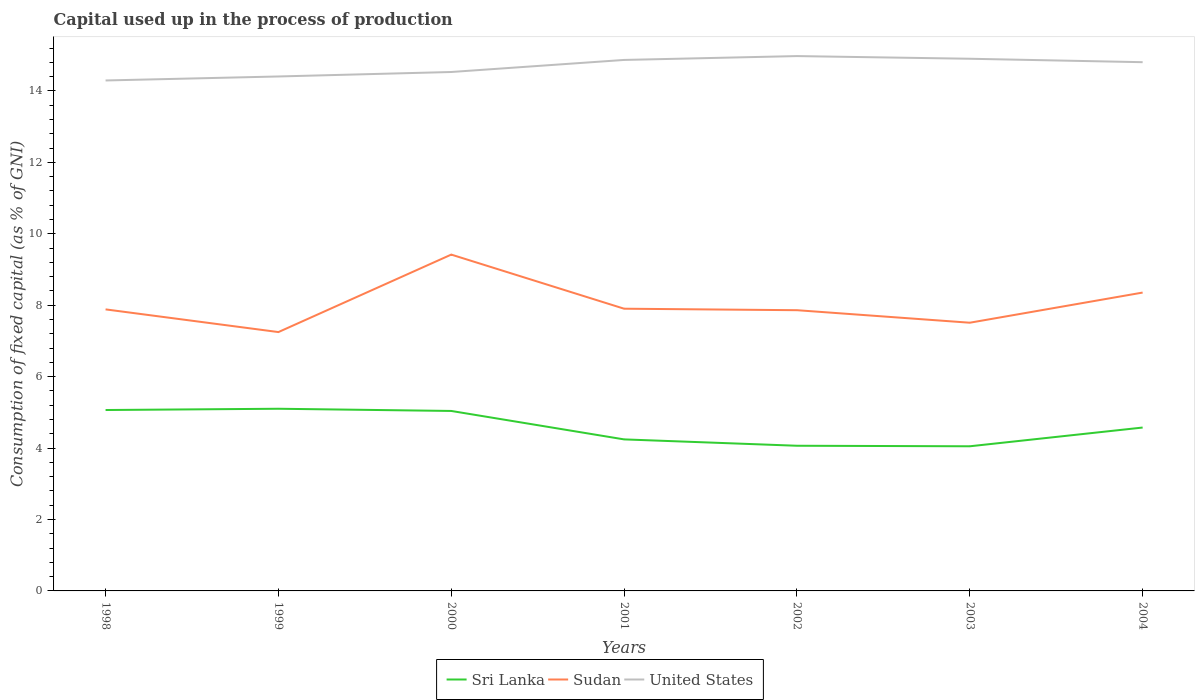Does the line corresponding to United States intersect with the line corresponding to Sudan?
Offer a very short reply. No. Across all years, what is the maximum capital used up in the process of production in Sudan?
Keep it short and to the point. 7.25. What is the total capital used up in the process of production in United States in the graph?
Ensure brevity in your answer.  -0.61. What is the difference between the highest and the second highest capital used up in the process of production in Sudan?
Offer a terse response. 2.17. What is the difference between the highest and the lowest capital used up in the process of production in Sri Lanka?
Give a very brief answer. 3. Are the values on the major ticks of Y-axis written in scientific E-notation?
Offer a very short reply. No. Does the graph contain grids?
Your answer should be compact. No. How many legend labels are there?
Provide a succinct answer. 3. What is the title of the graph?
Keep it short and to the point. Capital used up in the process of production. What is the label or title of the Y-axis?
Make the answer very short. Consumption of fixed capital (as % of GNI). What is the Consumption of fixed capital (as % of GNI) of Sri Lanka in 1998?
Provide a short and direct response. 5.07. What is the Consumption of fixed capital (as % of GNI) of Sudan in 1998?
Your answer should be compact. 7.88. What is the Consumption of fixed capital (as % of GNI) in United States in 1998?
Provide a succinct answer. 14.29. What is the Consumption of fixed capital (as % of GNI) in Sri Lanka in 1999?
Ensure brevity in your answer.  5.1. What is the Consumption of fixed capital (as % of GNI) of Sudan in 1999?
Give a very brief answer. 7.25. What is the Consumption of fixed capital (as % of GNI) of United States in 1999?
Your answer should be compact. 14.4. What is the Consumption of fixed capital (as % of GNI) of Sri Lanka in 2000?
Provide a short and direct response. 5.04. What is the Consumption of fixed capital (as % of GNI) of Sudan in 2000?
Your answer should be very brief. 9.42. What is the Consumption of fixed capital (as % of GNI) of United States in 2000?
Ensure brevity in your answer.  14.53. What is the Consumption of fixed capital (as % of GNI) of Sri Lanka in 2001?
Your answer should be compact. 4.24. What is the Consumption of fixed capital (as % of GNI) of Sudan in 2001?
Your answer should be very brief. 7.9. What is the Consumption of fixed capital (as % of GNI) of United States in 2001?
Provide a short and direct response. 14.87. What is the Consumption of fixed capital (as % of GNI) in Sri Lanka in 2002?
Give a very brief answer. 4.06. What is the Consumption of fixed capital (as % of GNI) of Sudan in 2002?
Provide a succinct answer. 7.86. What is the Consumption of fixed capital (as % of GNI) of United States in 2002?
Provide a short and direct response. 14.98. What is the Consumption of fixed capital (as % of GNI) in Sri Lanka in 2003?
Provide a succinct answer. 4.05. What is the Consumption of fixed capital (as % of GNI) in Sudan in 2003?
Your answer should be compact. 7.51. What is the Consumption of fixed capital (as % of GNI) of United States in 2003?
Your response must be concise. 14.9. What is the Consumption of fixed capital (as % of GNI) in Sri Lanka in 2004?
Give a very brief answer. 4.57. What is the Consumption of fixed capital (as % of GNI) in Sudan in 2004?
Offer a terse response. 8.35. What is the Consumption of fixed capital (as % of GNI) of United States in 2004?
Give a very brief answer. 14.8. Across all years, what is the maximum Consumption of fixed capital (as % of GNI) of Sri Lanka?
Your answer should be very brief. 5.1. Across all years, what is the maximum Consumption of fixed capital (as % of GNI) of Sudan?
Keep it short and to the point. 9.42. Across all years, what is the maximum Consumption of fixed capital (as % of GNI) of United States?
Make the answer very short. 14.98. Across all years, what is the minimum Consumption of fixed capital (as % of GNI) in Sri Lanka?
Give a very brief answer. 4.05. Across all years, what is the minimum Consumption of fixed capital (as % of GNI) of Sudan?
Ensure brevity in your answer.  7.25. Across all years, what is the minimum Consumption of fixed capital (as % of GNI) of United States?
Your answer should be compact. 14.29. What is the total Consumption of fixed capital (as % of GNI) of Sri Lanka in the graph?
Make the answer very short. 32.14. What is the total Consumption of fixed capital (as % of GNI) in Sudan in the graph?
Offer a terse response. 56.17. What is the total Consumption of fixed capital (as % of GNI) in United States in the graph?
Your response must be concise. 102.78. What is the difference between the Consumption of fixed capital (as % of GNI) of Sri Lanka in 1998 and that in 1999?
Your answer should be compact. -0.04. What is the difference between the Consumption of fixed capital (as % of GNI) in Sudan in 1998 and that in 1999?
Ensure brevity in your answer.  0.64. What is the difference between the Consumption of fixed capital (as % of GNI) of United States in 1998 and that in 1999?
Make the answer very short. -0.11. What is the difference between the Consumption of fixed capital (as % of GNI) of Sri Lanka in 1998 and that in 2000?
Provide a succinct answer. 0.03. What is the difference between the Consumption of fixed capital (as % of GNI) of Sudan in 1998 and that in 2000?
Your answer should be compact. -1.53. What is the difference between the Consumption of fixed capital (as % of GNI) of United States in 1998 and that in 2000?
Keep it short and to the point. -0.24. What is the difference between the Consumption of fixed capital (as % of GNI) of Sri Lanka in 1998 and that in 2001?
Your answer should be very brief. 0.82. What is the difference between the Consumption of fixed capital (as % of GNI) of Sudan in 1998 and that in 2001?
Your answer should be compact. -0.02. What is the difference between the Consumption of fixed capital (as % of GNI) in United States in 1998 and that in 2001?
Make the answer very short. -0.57. What is the difference between the Consumption of fixed capital (as % of GNI) in Sri Lanka in 1998 and that in 2002?
Offer a very short reply. 1. What is the difference between the Consumption of fixed capital (as % of GNI) of Sudan in 1998 and that in 2002?
Your response must be concise. 0.02. What is the difference between the Consumption of fixed capital (as % of GNI) in United States in 1998 and that in 2002?
Your answer should be very brief. -0.68. What is the difference between the Consumption of fixed capital (as % of GNI) in Sri Lanka in 1998 and that in 2003?
Give a very brief answer. 1.02. What is the difference between the Consumption of fixed capital (as % of GNI) of Sudan in 1998 and that in 2003?
Your answer should be compact. 0.37. What is the difference between the Consumption of fixed capital (as % of GNI) in United States in 1998 and that in 2003?
Provide a short and direct response. -0.61. What is the difference between the Consumption of fixed capital (as % of GNI) in Sri Lanka in 1998 and that in 2004?
Provide a succinct answer. 0.49. What is the difference between the Consumption of fixed capital (as % of GNI) of Sudan in 1998 and that in 2004?
Offer a very short reply. -0.47. What is the difference between the Consumption of fixed capital (as % of GNI) of United States in 1998 and that in 2004?
Provide a short and direct response. -0.51. What is the difference between the Consumption of fixed capital (as % of GNI) of Sri Lanka in 1999 and that in 2000?
Make the answer very short. 0.06. What is the difference between the Consumption of fixed capital (as % of GNI) of Sudan in 1999 and that in 2000?
Your answer should be compact. -2.17. What is the difference between the Consumption of fixed capital (as % of GNI) of United States in 1999 and that in 2000?
Give a very brief answer. -0.13. What is the difference between the Consumption of fixed capital (as % of GNI) of Sri Lanka in 1999 and that in 2001?
Provide a succinct answer. 0.86. What is the difference between the Consumption of fixed capital (as % of GNI) in Sudan in 1999 and that in 2001?
Give a very brief answer. -0.65. What is the difference between the Consumption of fixed capital (as % of GNI) of United States in 1999 and that in 2001?
Your answer should be compact. -0.46. What is the difference between the Consumption of fixed capital (as % of GNI) of Sri Lanka in 1999 and that in 2002?
Give a very brief answer. 1.04. What is the difference between the Consumption of fixed capital (as % of GNI) of Sudan in 1999 and that in 2002?
Your response must be concise. -0.61. What is the difference between the Consumption of fixed capital (as % of GNI) in United States in 1999 and that in 2002?
Your response must be concise. -0.57. What is the difference between the Consumption of fixed capital (as % of GNI) in Sri Lanka in 1999 and that in 2003?
Your answer should be very brief. 1.05. What is the difference between the Consumption of fixed capital (as % of GNI) of Sudan in 1999 and that in 2003?
Make the answer very short. -0.26. What is the difference between the Consumption of fixed capital (as % of GNI) of United States in 1999 and that in 2003?
Provide a succinct answer. -0.5. What is the difference between the Consumption of fixed capital (as % of GNI) in Sri Lanka in 1999 and that in 2004?
Offer a very short reply. 0.53. What is the difference between the Consumption of fixed capital (as % of GNI) in Sudan in 1999 and that in 2004?
Offer a very short reply. -1.11. What is the difference between the Consumption of fixed capital (as % of GNI) in United States in 1999 and that in 2004?
Make the answer very short. -0.4. What is the difference between the Consumption of fixed capital (as % of GNI) in Sri Lanka in 2000 and that in 2001?
Make the answer very short. 0.8. What is the difference between the Consumption of fixed capital (as % of GNI) of Sudan in 2000 and that in 2001?
Provide a succinct answer. 1.51. What is the difference between the Consumption of fixed capital (as % of GNI) in United States in 2000 and that in 2001?
Give a very brief answer. -0.34. What is the difference between the Consumption of fixed capital (as % of GNI) of Sri Lanka in 2000 and that in 2002?
Give a very brief answer. 0.97. What is the difference between the Consumption of fixed capital (as % of GNI) in Sudan in 2000 and that in 2002?
Keep it short and to the point. 1.56. What is the difference between the Consumption of fixed capital (as % of GNI) of United States in 2000 and that in 2002?
Ensure brevity in your answer.  -0.45. What is the difference between the Consumption of fixed capital (as % of GNI) in Sudan in 2000 and that in 2003?
Provide a short and direct response. 1.91. What is the difference between the Consumption of fixed capital (as % of GNI) in United States in 2000 and that in 2003?
Offer a terse response. -0.37. What is the difference between the Consumption of fixed capital (as % of GNI) of Sri Lanka in 2000 and that in 2004?
Your answer should be very brief. 0.46. What is the difference between the Consumption of fixed capital (as % of GNI) of Sudan in 2000 and that in 2004?
Offer a terse response. 1.06. What is the difference between the Consumption of fixed capital (as % of GNI) in United States in 2000 and that in 2004?
Give a very brief answer. -0.27. What is the difference between the Consumption of fixed capital (as % of GNI) in Sri Lanka in 2001 and that in 2002?
Your response must be concise. 0.18. What is the difference between the Consumption of fixed capital (as % of GNI) of Sudan in 2001 and that in 2002?
Provide a short and direct response. 0.04. What is the difference between the Consumption of fixed capital (as % of GNI) in United States in 2001 and that in 2002?
Make the answer very short. -0.11. What is the difference between the Consumption of fixed capital (as % of GNI) in Sri Lanka in 2001 and that in 2003?
Your answer should be very brief. 0.19. What is the difference between the Consumption of fixed capital (as % of GNI) of Sudan in 2001 and that in 2003?
Keep it short and to the point. 0.39. What is the difference between the Consumption of fixed capital (as % of GNI) in United States in 2001 and that in 2003?
Ensure brevity in your answer.  -0.03. What is the difference between the Consumption of fixed capital (as % of GNI) in Sri Lanka in 2001 and that in 2004?
Offer a very short reply. -0.33. What is the difference between the Consumption of fixed capital (as % of GNI) in Sudan in 2001 and that in 2004?
Give a very brief answer. -0.45. What is the difference between the Consumption of fixed capital (as % of GNI) of United States in 2001 and that in 2004?
Your answer should be very brief. 0.06. What is the difference between the Consumption of fixed capital (as % of GNI) in Sri Lanka in 2002 and that in 2003?
Provide a short and direct response. 0.01. What is the difference between the Consumption of fixed capital (as % of GNI) in Sudan in 2002 and that in 2003?
Ensure brevity in your answer.  0.35. What is the difference between the Consumption of fixed capital (as % of GNI) of United States in 2002 and that in 2003?
Your answer should be very brief. 0.07. What is the difference between the Consumption of fixed capital (as % of GNI) in Sri Lanka in 2002 and that in 2004?
Give a very brief answer. -0.51. What is the difference between the Consumption of fixed capital (as % of GNI) of Sudan in 2002 and that in 2004?
Keep it short and to the point. -0.49. What is the difference between the Consumption of fixed capital (as % of GNI) in United States in 2002 and that in 2004?
Keep it short and to the point. 0.17. What is the difference between the Consumption of fixed capital (as % of GNI) of Sri Lanka in 2003 and that in 2004?
Give a very brief answer. -0.52. What is the difference between the Consumption of fixed capital (as % of GNI) of Sudan in 2003 and that in 2004?
Provide a succinct answer. -0.84. What is the difference between the Consumption of fixed capital (as % of GNI) in United States in 2003 and that in 2004?
Provide a short and direct response. 0.1. What is the difference between the Consumption of fixed capital (as % of GNI) in Sri Lanka in 1998 and the Consumption of fixed capital (as % of GNI) in Sudan in 1999?
Offer a very short reply. -2.18. What is the difference between the Consumption of fixed capital (as % of GNI) of Sri Lanka in 1998 and the Consumption of fixed capital (as % of GNI) of United States in 1999?
Keep it short and to the point. -9.34. What is the difference between the Consumption of fixed capital (as % of GNI) in Sudan in 1998 and the Consumption of fixed capital (as % of GNI) in United States in 1999?
Ensure brevity in your answer.  -6.52. What is the difference between the Consumption of fixed capital (as % of GNI) in Sri Lanka in 1998 and the Consumption of fixed capital (as % of GNI) in Sudan in 2000?
Ensure brevity in your answer.  -4.35. What is the difference between the Consumption of fixed capital (as % of GNI) in Sri Lanka in 1998 and the Consumption of fixed capital (as % of GNI) in United States in 2000?
Provide a succinct answer. -9.46. What is the difference between the Consumption of fixed capital (as % of GNI) in Sudan in 1998 and the Consumption of fixed capital (as % of GNI) in United States in 2000?
Your response must be concise. -6.65. What is the difference between the Consumption of fixed capital (as % of GNI) of Sri Lanka in 1998 and the Consumption of fixed capital (as % of GNI) of Sudan in 2001?
Your answer should be very brief. -2.84. What is the difference between the Consumption of fixed capital (as % of GNI) in Sri Lanka in 1998 and the Consumption of fixed capital (as % of GNI) in United States in 2001?
Your answer should be compact. -9.8. What is the difference between the Consumption of fixed capital (as % of GNI) of Sudan in 1998 and the Consumption of fixed capital (as % of GNI) of United States in 2001?
Give a very brief answer. -6.98. What is the difference between the Consumption of fixed capital (as % of GNI) in Sri Lanka in 1998 and the Consumption of fixed capital (as % of GNI) in Sudan in 2002?
Ensure brevity in your answer.  -2.79. What is the difference between the Consumption of fixed capital (as % of GNI) of Sri Lanka in 1998 and the Consumption of fixed capital (as % of GNI) of United States in 2002?
Give a very brief answer. -9.91. What is the difference between the Consumption of fixed capital (as % of GNI) in Sudan in 1998 and the Consumption of fixed capital (as % of GNI) in United States in 2002?
Your answer should be compact. -7.09. What is the difference between the Consumption of fixed capital (as % of GNI) of Sri Lanka in 1998 and the Consumption of fixed capital (as % of GNI) of Sudan in 2003?
Your response must be concise. -2.44. What is the difference between the Consumption of fixed capital (as % of GNI) of Sri Lanka in 1998 and the Consumption of fixed capital (as % of GNI) of United States in 2003?
Offer a very short reply. -9.84. What is the difference between the Consumption of fixed capital (as % of GNI) of Sudan in 1998 and the Consumption of fixed capital (as % of GNI) of United States in 2003?
Ensure brevity in your answer.  -7.02. What is the difference between the Consumption of fixed capital (as % of GNI) of Sri Lanka in 1998 and the Consumption of fixed capital (as % of GNI) of Sudan in 2004?
Your response must be concise. -3.29. What is the difference between the Consumption of fixed capital (as % of GNI) in Sri Lanka in 1998 and the Consumption of fixed capital (as % of GNI) in United States in 2004?
Give a very brief answer. -9.74. What is the difference between the Consumption of fixed capital (as % of GNI) of Sudan in 1998 and the Consumption of fixed capital (as % of GNI) of United States in 2004?
Provide a short and direct response. -6.92. What is the difference between the Consumption of fixed capital (as % of GNI) in Sri Lanka in 1999 and the Consumption of fixed capital (as % of GNI) in Sudan in 2000?
Offer a very short reply. -4.32. What is the difference between the Consumption of fixed capital (as % of GNI) in Sri Lanka in 1999 and the Consumption of fixed capital (as % of GNI) in United States in 2000?
Provide a short and direct response. -9.43. What is the difference between the Consumption of fixed capital (as % of GNI) of Sudan in 1999 and the Consumption of fixed capital (as % of GNI) of United States in 2000?
Your response must be concise. -7.28. What is the difference between the Consumption of fixed capital (as % of GNI) of Sri Lanka in 1999 and the Consumption of fixed capital (as % of GNI) of Sudan in 2001?
Offer a terse response. -2.8. What is the difference between the Consumption of fixed capital (as % of GNI) in Sri Lanka in 1999 and the Consumption of fixed capital (as % of GNI) in United States in 2001?
Provide a succinct answer. -9.77. What is the difference between the Consumption of fixed capital (as % of GNI) in Sudan in 1999 and the Consumption of fixed capital (as % of GNI) in United States in 2001?
Provide a succinct answer. -7.62. What is the difference between the Consumption of fixed capital (as % of GNI) in Sri Lanka in 1999 and the Consumption of fixed capital (as % of GNI) in Sudan in 2002?
Keep it short and to the point. -2.76. What is the difference between the Consumption of fixed capital (as % of GNI) of Sri Lanka in 1999 and the Consumption of fixed capital (as % of GNI) of United States in 2002?
Your answer should be compact. -9.87. What is the difference between the Consumption of fixed capital (as % of GNI) in Sudan in 1999 and the Consumption of fixed capital (as % of GNI) in United States in 2002?
Your answer should be compact. -7.73. What is the difference between the Consumption of fixed capital (as % of GNI) of Sri Lanka in 1999 and the Consumption of fixed capital (as % of GNI) of Sudan in 2003?
Your response must be concise. -2.41. What is the difference between the Consumption of fixed capital (as % of GNI) in Sri Lanka in 1999 and the Consumption of fixed capital (as % of GNI) in United States in 2003?
Your answer should be very brief. -9.8. What is the difference between the Consumption of fixed capital (as % of GNI) in Sudan in 1999 and the Consumption of fixed capital (as % of GNI) in United States in 2003?
Your answer should be compact. -7.65. What is the difference between the Consumption of fixed capital (as % of GNI) of Sri Lanka in 1999 and the Consumption of fixed capital (as % of GNI) of Sudan in 2004?
Make the answer very short. -3.25. What is the difference between the Consumption of fixed capital (as % of GNI) of Sri Lanka in 1999 and the Consumption of fixed capital (as % of GNI) of United States in 2004?
Make the answer very short. -9.7. What is the difference between the Consumption of fixed capital (as % of GNI) of Sudan in 1999 and the Consumption of fixed capital (as % of GNI) of United States in 2004?
Ensure brevity in your answer.  -7.56. What is the difference between the Consumption of fixed capital (as % of GNI) in Sri Lanka in 2000 and the Consumption of fixed capital (as % of GNI) in Sudan in 2001?
Your response must be concise. -2.86. What is the difference between the Consumption of fixed capital (as % of GNI) in Sri Lanka in 2000 and the Consumption of fixed capital (as % of GNI) in United States in 2001?
Provide a succinct answer. -9.83. What is the difference between the Consumption of fixed capital (as % of GNI) of Sudan in 2000 and the Consumption of fixed capital (as % of GNI) of United States in 2001?
Your answer should be compact. -5.45. What is the difference between the Consumption of fixed capital (as % of GNI) of Sri Lanka in 2000 and the Consumption of fixed capital (as % of GNI) of Sudan in 2002?
Your answer should be very brief. -2.82. What is the difference between the Consumption of fixed capital (as % of GNI) of Sri Lanka in 2000 and the Consumption of fixed capital (as % of GNI) of United States in 2002?
Offer a very short reply. -9.94. What is the difference between the Consumption of fixed capital (as % of GNI) of Sudan in 2000 and the Consumption of fixed capital (as % of GNI) of United States in 2002?
Make the answer very short. -5.56. What is the difference between the Consumption of fixed capital (as % of GNI) of Sri Lanka in 2000 and the Consumption of fixed capital (as % of GNI) of Sudan in 2003?
Your answer should be very brief. -2.47. What is the difference between the Consumption of fixed capital (as % of GNI) of Sri Lanka in 2000 and the Consumption of fixed capital (as % of GNI) of United States in 2003?
Provide a succinct answer. -9.86. What is the difference between the Consumption of fixed capital (as % of GNI) of Sudan in 2000 and the Consumption of fixed capital (as % of GNI) of United States in 2003?
Your response must be concise. -5.48. What is the difference between the Consumption of fixed capital (as % of GNI) in Sri Lanka in 2000 and the Consumption of fixed capital (as % of GNI) in Sudan in 2004?
Ensure brevity in your answer.  -3.32. What is the difference between the Consumption of fixed capital (as % of GNI) of Sri Lanka in 2000 and the Consumption of fixed capital (as % of GNI) of United States in 2004?
Make the answer very short. -9.77. What is the difference between the Consumption of fixed capital (as % of GNI) in Sudan in 2000 and the Consumption of fixed capital (as % of GNI) in United States in 2004?
Your answer should be compact. -5.39. What is the difference between the Consumption of fixed capital (as % of GNI) in Sri Lanka in 2001 and the Consumption of fixed capital (as % of GNI) in Sudan in 2002?
Provide a succinct answer. -3.62. What is the difference between the Consumption of fixed capital (as % of GNI) in Sri Lanka in 2001 and the Consumption of fixed capital (as % of GNI) in United States in 2002?
Give a very brief answer. -10.73. What is the difference between the Consumption of fixed capital (as % of GNI) in Sudan in 2001 and the Consumption of fixed capital (as % of GNI) in United States in 2002?
Offer a terse response. -7.07. What is the difference between the Consumption of fixed capital (as % of GNI) of Sri Lanka in 2001 and the Consumption of fixed capital (as % of GNI) of Sudan in 2003?
Ensure brevity in your answer.  -3.27. What is the difference between the Consumption of fixed capital (as % of GNI) in Sri Lanka in 2001 and the Consumption of fixed capital (as % of GNI) in United States in 2003?
Provide a short and direct response. -10.66. What is the difference between the Consumption of fixed capital (as % of GNI) in Sudan in 2001 and the Consumption of fixed capital (as % of GNI) in United States in 2003?
Ensure brevity in your answer.  -7. What is the difference between the Consumption of fixed capital (as % of GNI) in Sri Lanka in 2001 and the Consumption of fixed capital (as % of GNI) in Sudan in 2004?
Keep it short and to the point. -4.11. What is the difference between the Consumption of fixed capital (as % of GNI) of Sri Lanka in 2001 and the Consumption of fixed capital (as % of GNI) of United States in 2004?
Make the answer very short. -10.56. What is the difference between the Consumption of fixed capital (as % of GNI) of Sudan in 2001 and the Consumption of fixed capital (as % of GNI) of United States in 2004?
Your answer should be compact. -6.9. What is the difference between the Consumption of fixed capital (as % of GNI) of Sri Lanka in 2002 and the Consumption of fixed capital (as % of GNI) of Sudan in 2003?
Give a very brief answer. -3.44. What is the difference between the Consumption of fixed capital (as % of GNI) in Sri Lanka in 2002 and the Consumption of fixed capital (as % of GNI) in United States in 2003?
Your answer should be very brief. -10.84. What is the difference between the Consumption of fixed capital (as % of GNI) of Sudan in 2002 and the Consumption of fixed capital (as % of GNI) of United States in 2003?
Give a very brief answer. -7.04. What is the difference between the Consumption of fixed capital (as % of GNI) in Sri Lanka in 2002 and the Consumption of fixed capital (as % of GNI) in Sudan in 2004?
Offer a very short reply. -4.29. What is the difference between the Consumption of fixed capital (as % of GNI) of Sri Lanka in 2002 and the Consumption of fixed capital (as % of GNI) of United States in 2004?
Offer a terse response. -10.74. What is the difference between the Consumption of fixed capital (as % of GNI) of Sudan in 2002 and the Consumption of fixed capital (as % of GNI) of United States in 2004?
Ensure brevity in your answer.  -6.94. What is the difference between the Consumption of fixed capital (as % of GNI) of Sri Lanka in 2003 and the Consumption of fixed capital (as % of GNI) of Sudan in 2004?
Ensure brevity in your answer.  -4.3. What is the difference between the Consumption of fixed capital (as % of GNI) in Sri Lanka in 2003 and the Consumption of fixed capital (as % of GNI) in United States in 2004?
Offer a terse response. -10.75. What is the difference between the Consumption of fixed capital (as % of GNI) of Sudan in 2003 and the Consumption of fixed capital (as % of GNI) of United States in 2004?
Your response must be concise. -7.29. What is the average Consumption of fixed capital (as % of GNI) of Sri Lanka per year?
Provide a short and direct response. 4.59. What is the average Consumption of fixed capital (as % of GNI) of Sudan per year?
Offer a very short reply. 8.02. What is the average Consumption of fixed capital (as % of GNI) in United States per year?
Provide a succinct answer. 14.68. In the year 1998, what is the difference between the Consumption of fixed capital (as % of GNI) in Sri Lanka and Consumption of fixed capital (as % of GNI) in Sudan?
Make the answer very short. -2.82. In the year 1998, what is the difference between the Consumption of fixed capital (as % of GNI) in Sri Lanka and Consumption of fixed capital (as % of GNI) in United States?
Ensure brevity in your answer.  -9.23. In the year 1998, what is the difference between the Consumption of fixed capital (as % of GNI) of Sudan and Consumption of fixed capital (as % of GNI) of United States?
Your answer should be very brief. -6.41. In the year 1999, what is the difference between the Consumption of fixed capital (as % of GNI) of Sri Lanka and Consumption of fixed capital (as % of GNI) of Sudan?
Give a very brief answer. -2.15. In the year 1999, what is the difference between the Consumption of fixed capital (as % of GNI) of Sri Lanka and Consumption of fixed capital (as % of GNI) of United States?
Provide a short and direct response. -9.3. In the year 1999, what is the difference between the Consumption of fixed capital (as % of GNI) of Sudan and Consumption of fixed capital (as % of GNI) of United States?
Keep it short and to the point. -7.16. In the year 2000, what is the difference between the Consumption of fixed capital (as % of GNI) of Sri Lanka and Consumption of fixed capital (as % of GNI) of Sudan?
Ensure brevity in your answer.  -4.38. In the year 2000, what is the difference between the Consumption of fixed capital (as % of GNI) in Sri Lanka and Consumption of fixed capital (as % of GNI) in United States?
Provide a succinct answer. -9.49. In the year 2000, what is the difference between the Consumption of fixed capital (as % of GNI) in Sudan and Consumption of fixed capital (as % of GNI) in United States?
Provide a succinct answer. -5.11. In the year 2001, what is the difference between the Consumption of fixed capital (as % of GNI) of Sri Lanka and Consumption of fixed capital (as % of GNI) of Sudan?
Offer a very short reply. -3.66. In the year 2001, what is the difference between the Consumption of fixed capital (as % of GNI) in Sri Lanka and Consumption of fixed capital (as % of GNI) in United States?
Provide a succinct answer. -10.62. In the year 2001, what is the difference between the Consumption of fixed capital (as % of GNI) of Sudan and Consumption of fixed capital (as % of GNI) of United States?
Offer a very short reply. -6.97. In the year 2002, what is the difference between the Consumption of fixed capital (as % of GNI) in Sri Lanka and Consumption of fixed capital (as % of GNI) in Sudan?
Ensure brevity in your answer.  -3.8. In the year 2002, what is the difference between the Consumption of fixed capital (as % of GNI) of Sri Lanka and Consumption of fixed capital (as % of GNI) of United States?
Your response must be concise. -10.91. In the year 2002, what is the difference between the Consumption of fixed capital (as % of GNI) of Sudan and Consumption of fixed capital (as % of GNI) of United States?
Your answer should be compact. -7.12. In the year 2003, what is the difference between the Consumption of fixed capital (as % of GNI) of Sri Lanka and Consumption of fixed capital (as % of GNI) of Sudan?
Make the answer very short. -3.46. In the year 2003, what is the difference between the Consumption of fixed capital (as % of GNI) of Sri Lanka and Consumption of fixed capital (as % of GNI) of United States?
Your answer should be compact. -10.85. In the year 2003, what is the difference between the Consumption of fixed capital (as % of GNI) in Sudan and Consumption of fixed capital (as % of GNI) in United States?
Offer a very short reply. -7.39. In the year 2004, what is the difference between the Consumption of fixed capital (as % of GNI) of Sri Lanka and Consumption of fixed capital (as % of GNI) of Sudan?
Your answer should be compact. -3.78. In the year 2004, what is the difference between the Consumption of fixed capital (as % of GNI) of Sri Lanka and Consumption of fixed capital (as % of GNI) of United States?
Ensure brevity in your answer.  -10.23. In the year 2004, what is the difference between the Consumption of fixed capital (as % of GNI) of Sudan and Consumption of fixed capital (as % of GNI) of United States?
Offer a terse response. -6.45. What is the ratio of the Consumption of fixed capital (as % of GNI) of Sri Lanka in 1998 to that in 1999?
Offer a very short reply. 0.99. What is the ratio of the Consumption of fixed capital (as % of GNI) in Sudan in 1998 to that in 1999?
Ensure brevity in your answer.  1.09. What is the ratio of the Consumption of fixed capital (as % of GNI) in United States in 1998 to that in 1999?
Give a very brief answer. 0.99. What is the ratio of the Consumption of fixed capital (as % of GNI) in Sri Lanka in 1998 to that in 2000?
Offer a very short reply. 1.01. What is the ratio of the Consumption of fixed capital (as % of GNI) in Sudan in 1998 to that in 2000?
Keep it short and to the point. 0.84. What is the ratio of the Consumption of fixed capital (as % of GNI) in United States in 1998 to that in 2000?
Provide a succinct answer. 0.98. What is the ratio of the Consumption of fixed capital (as % of GNI) of Sri Lanka in 1998 to that in 2001?
Your answer should be very brief. 1.19. What is the ratio of the Consumption of fixed capital (as % of GNI) in Sudan in 1998 to that in 2001?
Make the answer very short. 1. What is the ratio of the Consumption of fixed capital (as % of GNI) in United States in 1998 to that in 2001?
Ensure brevity in your answer.  0.96. What is the ratio of the Consumption of fixed capital (as % of GNI) of Sri Lanka in 1998 to that in 2002?
Your answer should be very brief. 1.25. What is the ratio of the Consumption of fixed capital (as % of GNI) in United States in 1998 to that in 2002?
Ensure brevity in your answer.  0.95. What is the ratio of the Consumption of fixed capital (as % of GNI) of Sri Lanka in 1998 to that in 2003?
Offer a terse response. 1.25. What is the ratio of the Consumption of fixed capital (as % of GNI) of Sudan in 1998 to that in 2003?
Ensure brevity in your answer.  1.05. What is the ratio of the Consumption of fixed capital (as % of GNI) in United States in 1998 to that in 2003?
Offer a terse response. 0.96. What is the ratio of the Consumption of fixed capital (as % of GNI) in Sri Lanka in 1998 to that in 2004?
Give a very brief answer. 1.11. What is the ratio of the Consumption of fixed capital (as % of GNI) of Sudan in 1998 to that in 2004?
Your answer should be very brief. 0.94. What is the ratio of the Consumption of fixed capital (as % of GNI) of United States in 1998 to that in 2004?
Ensure brevity in your answer.  0.97. What is the ratio of the Consumption of fixed capital (as % of GNI) of Sri Lanka in 1999 to that in 2000?
Offer a terse response. 1.01. What is the ratio of the Consumption of fixed capital (as % of GNI) of Sudan in 1999 to that in 2000?
Make the answer very short. 0.77. What is the ratio of the Consumption of fixed capital (as % of GNI) of United States in 1999 to that in 2000?
Your answer should be very brief. 0.99. What is the ratio of the Consumption of fixed capital (as % of GNI) of Sri Lanka in 1999 to that in 2001?
Your answer should be compact. 1.2. What is the ratio of the Consumption of fixed capital (as % of GNI) in Sudan in 1999 to that in 2001?
Offer a very short reply. 0.92. What is the ratio of the Consumption of fixed capital (as % of GNI) of United States in 1999 to that in 2001?
Keep it short and to the point. 0.97. What is the ratio of the Consumption of fixed capital (as % of GNI) in Sri Lanka in 1999 to that in 2002?
Offer a very short reply. 1.25. What is the ratio of the Consumption of fixed capital (as % of GNI) in Sudan in 1999 to that in 2002?
Make the answer very short. 0.92. What is the ratio of the Consumption of fixed capital (as % of GNI) in United States in 1999 to that in 2002?
Ensure brevity in your answer.  0.96. What is the ratio of the Consumption of fixed capital (as % of GNI) of Sri Lanka in 1999 to that in 2003?
Offer a terse response. 1.26. What is the ratio of the Consumption of fixed capital (as % of GNI) of Sudan in 1999 to that in 2003?
Offer a terse response. 0.97. What is the ratio of the Consumption of fixed capital (as % of GNI) in United States in 1999 to that in 2003?
Provide a short and direct response. 0.97. What is the ratio of the Consumption of fixed capital (as % of GNI) of Sri Lanka in 1999 to that in 2004?
Your response must be concise. 1.11. What is the ratio of the Consumption of fixed capital (as % of GNI) of Sudan in 1999 to that in 2004?
Provide a succinct answer. 0.87. What is the ratio of the Consumption of fixed capital (as % of GNI) in Sri Lanka in 2000 to that in 2001?
Offer a very short reply. 1.19. What is the ratio of the Consumption of fixed capital (as % of GNI) of Sudan in 2000 to that in 2001?
Your response must be concise. 1.19. What is the ratio of the Consumption of fixed capital (as % of GNI) in United States in 2000 to that in 2001?
Offer a terse response. 0.98. What is the ratio of the Consumption of fixed capital (as % of GNI) in Sri Lanka in 2000 to that in 2002?
Provide a succinct answer. 1.24. What is the ratio of the Consumption of fixed capital (as % of GNI) of Sudan in 2000 to that in 2002?
Provide a short and direct response. 1.2. What is the ratio of the Consumption of fixed capital (as % of GNI) of United States in 2000 to that in 2002?
Give a very brief answer. 0.97. What is the ratio of the Consumption of fixed capital (as % of GNI) in Sri Lanka in 2000 to that in 2003?
Give a very brief answer. 1.24. What is the ratio of the Consumption of fixed capital (as % of GNI) in Sudan in 2000 to that in 2003?
Your response must be concise. 1.25. What is the ratio of the Consumption of fixed capital (as % of GNI) of United States in 2000 to that in 2003?
Your response must be concise. 0.98. What is the ratio of the Consumption of fixed capital (as % of GNI) of Sri Lanka in 2000 to that in 2004?
Give a very brief answer. 1.1. What is the ratio of the Consumption of fixed capital (as % of GNI) in Sudan in 2000 to that in 2004?
Your answer should be very brief. 1.13. What is the ratio of the Consumption of fixed capital (as % of GNI) in United States in 2000 to that in 2004?
Offer a terse response. 0.98. What is the ratio of the Consumption of fixed capital (as % of GNI) in Sri Lanka in 2001 to that in 2002?
Provide a short and direct response. 1.04. What is the ratio of the Consumption of fixed capital (as % of GNI) in Sudan in 2001 to that in 2002?
Your response must be concise. 1.01. What is the ratio of the Consumption of fixed capital (as % of GNI) of United States in 2001 to that in 2002?
Provide a short and direct response. 0.99. What is the ratio of the Consumption of fixed capital (as % of GNI) of Sri Lanka in 2001 to that in 2003?
Your answer should be compact. 1.05. What is the ratio of the Consumption of fixed capital (as % of GNI) of Sudan in 2001 to that in 2003?
Provide a short and direct response. 1.05. What is the ratio of the Consumption of fixed capital (as % of GNI) of Sri Lanka in 2001 to that in 2004?
Offer a terse response. 0.93. What is the ratio of the Consumption of fixed capital (as % of GNI) in Sudan in 2001 to that in 2004?
Make the answer very short. 0.95. What is the ratio of the Consumption of fixed capital (as % of GNI) in Sudan in 2002 to that in 2003?
Provide a short and direct response. 1.05. What is the ratio of the Consumption of fixed capital (as % of GNI) of United States in 2002 to that in 2003?
Offer a very short reply. 1. What is the ratio of the Consumption of fixed capital (as % of GNI) in Sri Lanka in 2002 to that in 2004?
Make the answer very short. 0.89. What is the ratio of the Consumption of fixed capital (as % of GNI) in Sudan in 2002 to that in 2004?
Offer a terse response. 0.94. What is the ratio of the Consumption of fixed capital (as % of GNI) of United States in 2002 to that in 2004?
Keep it short and to the point. 1.01. What is the ratio of the Consumption of fixed capital (as % of GNI) in Sri Lanka in 2003 to that in 2004?
Your response must be concise. 0.89. What is the ratio of the Consumption of fixed capital (as % of GNI) in Sudan in 2003 to that in 2004?
Ensure brevity in your answer.  0.9. What is the difference between the highest and the second highest Consumption of fixed capital (as % of GNI) of Sri Lanka?
Offer a terse response. 0.04. What is the difference between the highest and the second highest Consumption of fixed capital (as % of GNI) of Sudan?
Keep it short and to the point. 1.06. What is the difference between the highest and the second highest Consumption of fixed capital (as % of GNI) in United States?
Provide a succinct answer. 0.07. What is the difference between the highest and the lowest Consumption of fixed capital (as % of GNI) of Sri Lanka?
Your response must be concise. 1.05. What is the difference between the highest and the lowest Consumption of fixed capital (as % of GNI) in Sudan?
Your answer should be compact. 2.17. What is the difference between the highest and the lowest Consumption of fixed capital (as % of GNI) in United States?
Ensure brevity in your answer.  0.68. 